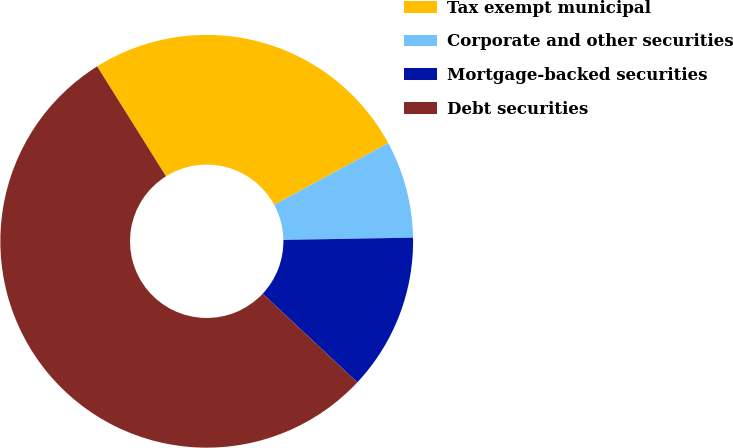<chart> <loc_0><loc_0><loc_500><loc_500><pie_chart><fcel>Tax exempt municipal<fcel>Corporate and other securities<fcel>Mortgage-backed securities<fcel>Debt securities<nl><fcel>26.02%<fcel>7.61%<fcel>12.26%<fcel>54.12%<nl></chart> 